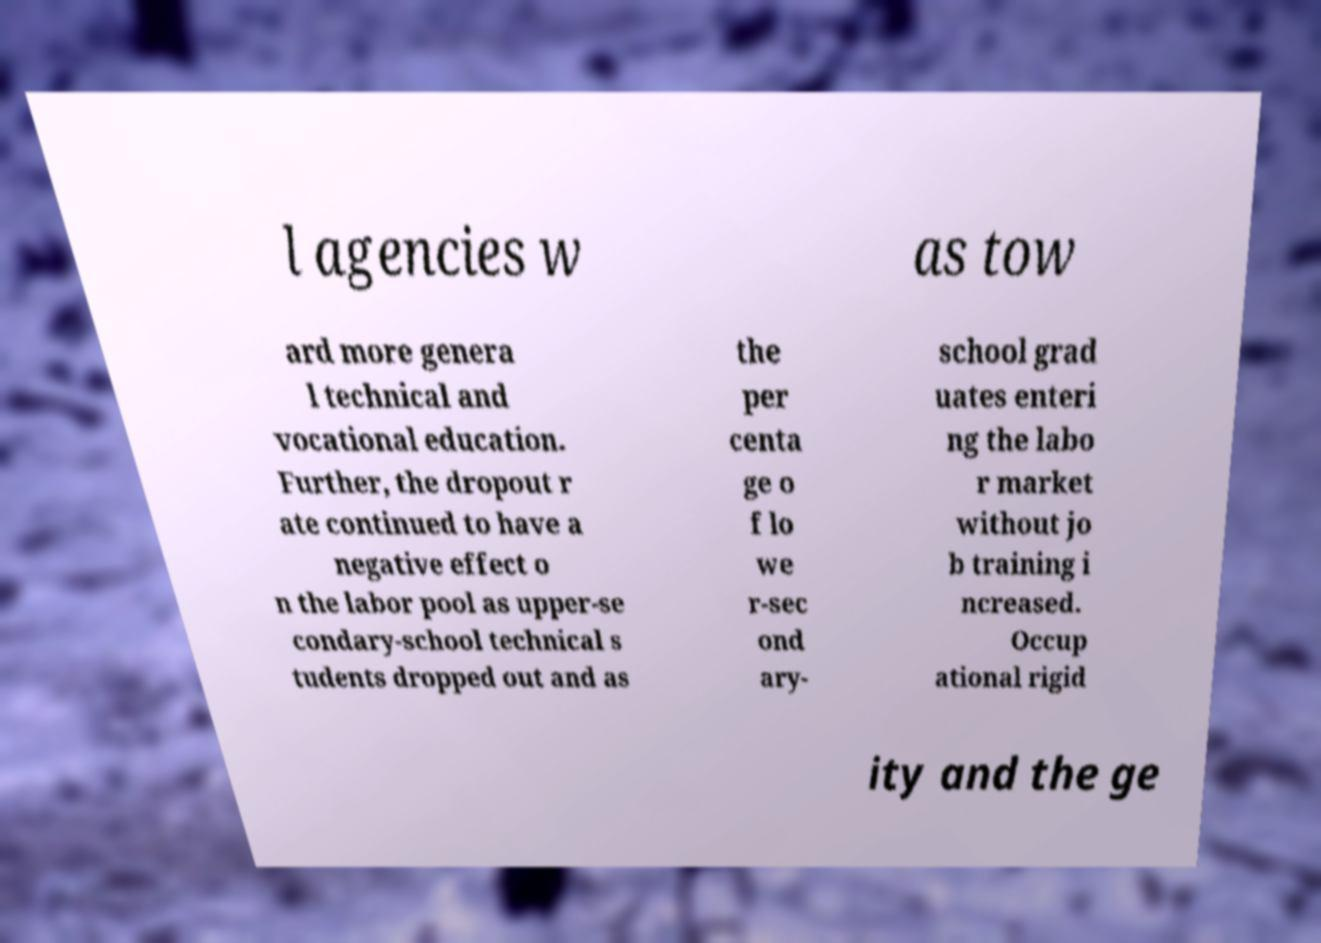Please identify and transcribe the text found in this image. l agencies w as tow ard more genera l technical and vocational education. Further, the dropout r ate continued to have a negative effect o n the labor pool as upper-se condary-school technical s tudents dropped out and as the per centa ge o f lo we r-sec ond ary- school grad uates enteri ng the labo r market without jo b training i ncreased. Occup ational rigid ity and the ge 